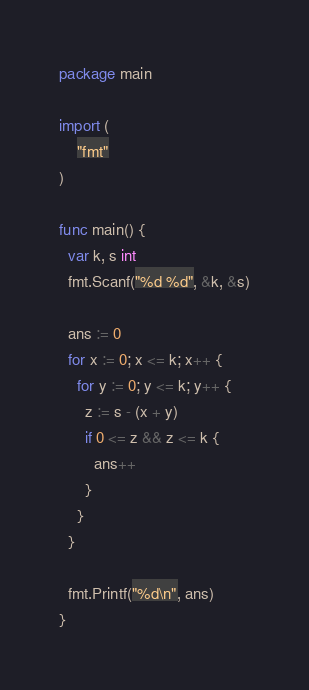<code> <loc_0><loc_0><loc_500><loc_500><_Go_>package main

import (
	"fmt"
)

func main() {
  var k, s int
  fmt.Scanf("%d %d", &k, &s)

  ans := 0
  for x := 0; x <= k; x++ {
    for y := 0; y <= k; y++ {
      z := s - (x + y)
      if 0 <= z && z <= k {
        ans++
      }
    }
  }
  
  fmt.Printf("%d\n", ans)
}</code> 